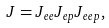Convert formula to latex. <formula><loc_0><loc_0><loc_500><loc_500>J = J _ { e e } J _ { e p } J _ { e e p } ,</formula> 